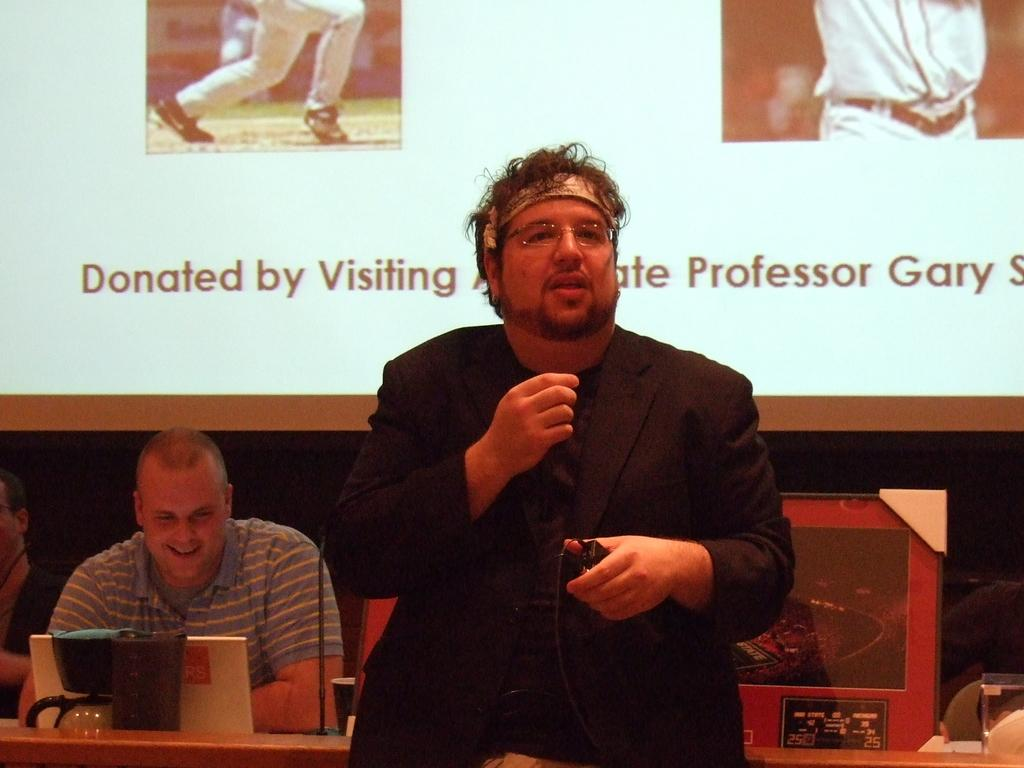What is the man in the image doing? The man is standing and holding a microphone. What is the man with the microphone doing? The man with the microphone is speaking. Can you describe the other person in the image? There is a seated man in the image, and he is smiling. What is visible on the screen in the image? The facts provided do not mention the content of the screen. How many people are present in the image? There are two people in the image: a standing man with a microphone and a seated man. What type of thrill can be seen on the ice square in the image? There is no ice square or thrill present in the image. 